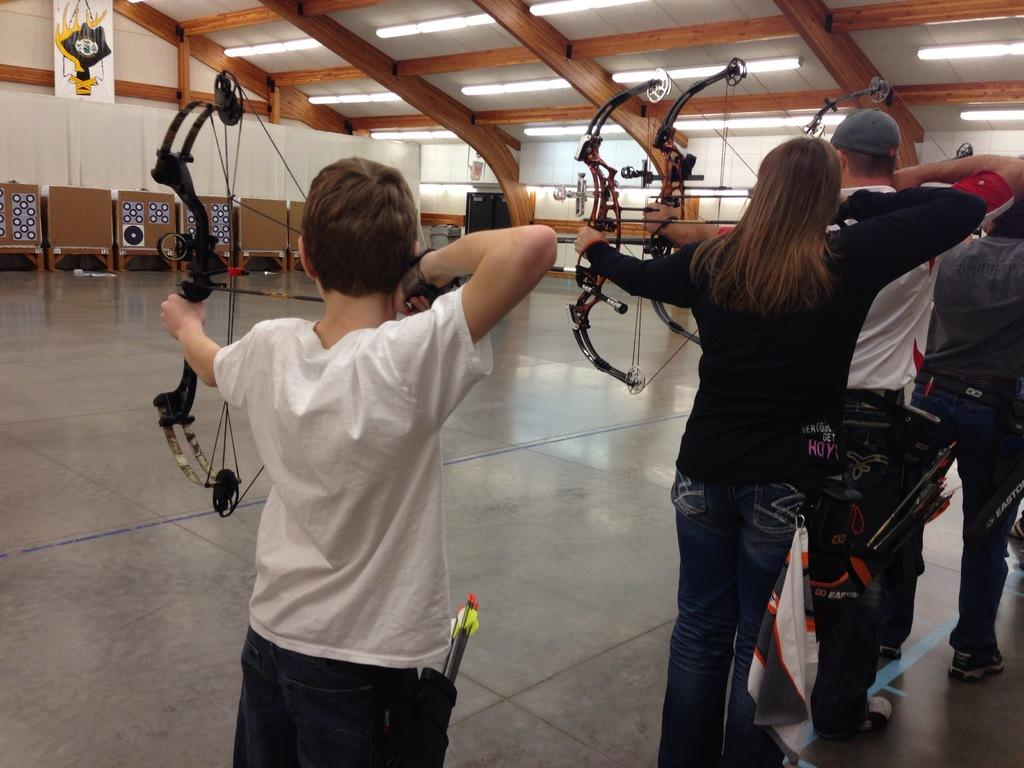What are the persons in the image holding? The persons in the image are holding archers. What can be seen in the background of the image? There are archery targets and a wall in the background of the image. What is providing illumination in the image? There are lights visible in the image. What type of plants can be seen growing on the wall in the image? There are no plants visible on the wall in the image. What wish is being granted to the persons holding archers in the image? There is no mention of a wish being granted in the image. 